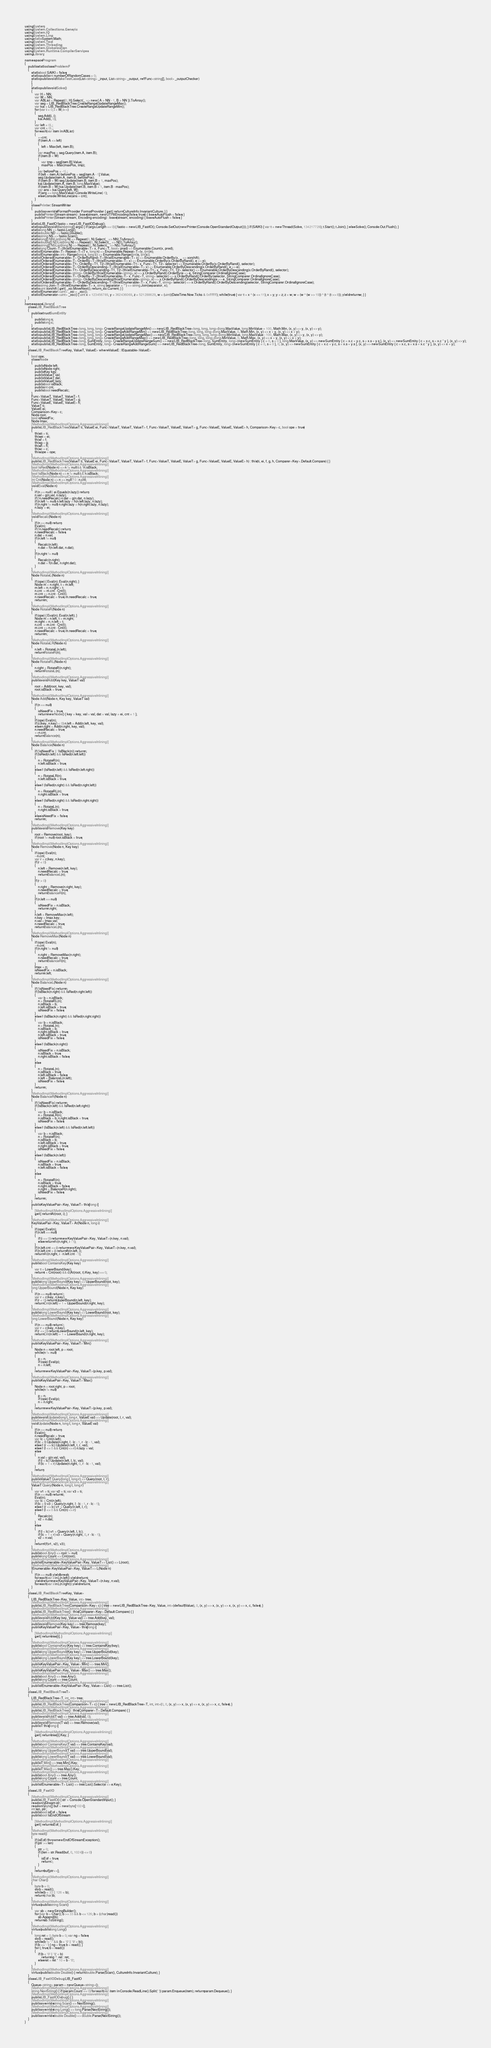Convert code to text. <code><loc_0><loc_0><loc_500><loc_500><_C#_>using System;
using System.Collections.Generic;
using System.IO;
using System.Linq;
using static System.Math;
using System.Text;
using System.Threading;
using System.Globalization;
using System.Runtime.CompilerServices;
using Library;

namespace Program
{
    public static class ProblemF
    {
        static bool SAIKI = false;
        static public int numberOfRandomCases = 0;
        static public void MakeTestCase(List<string> _input, List<string> _output, ref Func<string[], bool> _outputChecker)
        {
        }
        static public void Solve()
        {
            var H = NN;
            var W = NN;
            var ABList = Repeat(0, H).Select(_ => new { A = NN - 1, B = NN }).ToArray();
            var seg = LIB_RedBlackTree.CreateRangeUpdateRangeMax();
            var kai = LIB_RedBlackTree.CreateRangeUpdateRangeMin();
            for (var i = 0; i < W; i++)
            {
                seg.Add(i, i);
                kai.Add(i, 0);
            }
            var left = 0L;
            var cnt = 0L;
            foreach (var item in ABList)
            {
                ++cnt;
                if (item.A <= left)
                {
                    left = Max(left, item.B);
                }
                var maxPos = seg.Query(item.A, item.B);
                if (item.B < W)
                {
                    var tmp = seg[item.B].Value;
                    maxPos = Max(maxPos, tmp);
                }
                var beforePos = -1L;
                if (left < item.A) beforePos = seg[item.A - 1].Value;
                seg.Update(item.A, item.B, beforePos);
                if (item.B < W) seg.Update(item.B, item.B + 1, maxPos);
                kai.Update(item.A, item.B, long.MaxValue);
                if (item.B < W) kai.Update(item.B, item.B + 1, item.B - maxPos);
                var ans = kai.Query(left, W);
                if (ans == long.MaxValue) Console.WriteLine(-1);
                else Console.WriteLine(ans + cnt);
            }
        }
        class Printer : StreamWriter
        {
            public override IFormatProvider FormatProvider { get { return CultureInfo.InvariantCulture; } }
            public Printer(Stream stream) : base(stream, new UTF8Encoding(false, true)) { base.AutoFlush = false; }
            public Printer(Stream stream, Encoding encoding) : base(stream, encoding) { base.AutoFlush = false; }
        }
        static LIB_FastIO fastio = new LIB_FastIODebug();
        static public void Main(string[] args) { if (args.Length == 0) { fastio = new LIB_FastIO(); Console.SetOut(new Printer(Console.OpenStandardOutput())); } if (SAIKI) { var t = new Thread(Solve, 134217728); t.Start(); t.Join(); } else Solve(); Console.Out.Flush(); }
        static long NN => fastio.Long();
        static double ND => fastio.Double();
        static string NS => fastio.Scan();
        static long[] NNList(long N) => Repeat(0, N).Select(_ => NN).ToArray();
        static double[] NDList(long N) => Repeat(0, N).Select(_ => ND).ToArray();
        static string[] NSList(long N) => Repeat(0, N).Select(_ => NS).ToArray();
        static long Count<T>(this IEnumerable<T> x, Func<T, bool> pred) => Enumerable.Count(x, pred);
        static IEnumerable<T> Repeat<T>(T v, long n) => Enumerable.Repeat<T>(v, (int)n);
        static IEnumerable<int> Range(long s, long c) => Enumerable.Range((int)s, (int)c);
        static IOrderedEnumerable<T> OrderByRand<T>(this IEnumerable<T> x) => Enumerable.OrderBy(x, _ => xorshift);
        static IOrderedEnumerable<T> OrderBy<T>(this IEnumerable<T> x) => Enumerable.OrderBy(x.OrderByRand(), e => e);
        static IOrderedEnumerable<T1> OrderBy<T1, T2>(this IEnumerable<T1> x, Func<T1, T2> selector) => Enumerable.OrderBy(x.OrderByRand(), selector);
        static IOrderedEnumerable<T> OrderByDescending<T>(this IEnumerable<T> x) => Enumerable.OrderByDescending(x.OrderByRand(), e => e);
        static IOrderedEnumerable<T1> OrderByDescending<T1, T2>(this IEnumerable<T1> x, Func<T1, T2> selector) => Enumerable.OrderByDescending(x.OrderByRand(), selector);
        static IOrderedEnumerable<string> OrderBy(this IEnumerable<string> x) => x.OrderByRand().OrderBy(e => e, StringComparer.OrdinalIgnoreCase);
        static IOrderedEnumerable<T> OrderBy<T>(this IEnumerable<T> x, Func<T, string> selector) => x.OrderByRand().OrderBy(selector, StringComparer.OrdinalIgnoreCase);
        static IOrderedEnumerable<string> OrderByDescending(this IEnumerable<string> x) => x.OrderByRand().OrderByDescending(e => e, StringComparer.OrdinalIgnoreCase);
        static IOrderedEnumerable<T> OrderByDescending<T>(this IEnumerable<T> x, Func<T, string> selector) => x.OrderByRand().OrderByDescending(selector, StringComparer.OrdinalIgnoreCase);
        static string Join<T>(this IEnumerable<T> x, string separator = "") => string.Join(separator, x);
        static uint xorshift { get { _xsi.MoveNext(); return _xsi.Current; } }
        static IEnumerator<uint> _xsi = _xsc();
        static IEnumerator<uint> _xsc() { uint x = 123456789, y = 362436069, z = 521288629, w = (uint)(DateTime.Now.Ticks & 0xffffffff); while (true) { var t = x ^ (x << 11); x = y; y = z; z = w; w = (w ^ (w >> 19)) ^ (t ^ (t >> 8)); yield return w; } }
    }
}
namespace Library {
    class LIB_RedBlackTree
    {
        public struct SumEntity
        {
            public long s;
            public long c;
        }
        static public LIB_RedBlackTree<long, long, long> CreateRangeUpdateRangeMin() => new LIB_RedBlackTree<long, long, long>(long.MaxValue, long.MinValue + 100, Math.Min, (x, y) => y, (x, y) => y);
        static public LIB_RedBlackTree<long, long, long> CreateRangeAddRangeMin() => new LIB_RedBlackTree<long, long, long>(long.MaxValue, 0, Math.Min, (x, y) => x + y, (x, y) => x + y);
        static public LIB_RedBlackTree<long, long, long> CreateRangeUpdateRangeMax() => new LIB_RedBlackTree<long, long, long>(long.MinValue, long.MaxValue - 100, Math.Max, (x, y) => y, (x, y) => y);
        static public LIB_RedBlackTree<long, long, long> CreateRangeAddRangeMax() => new LIB_RedBlackTree<long, long, long>(long.MinValue, 0, Math.Max, (x, y) => x + y, (x, y) => x + y);
        static public LIB_RedBlackTree<long, SumEntity, long> CreateRangeUpdateRangeSum() => new LIB_RedBlackTree<long, SumEntity, long>(new SumEntity { c = 0, s = 0 }, long.MaxValue, (x, y) => new SumEntity { c = x.c + y.c, s = x.s + y.s }, (x, y) => new SumEntity { c = x.c, s = x.c * y }, (x, y) => y);
        static public LIB_RedBlackTree<long, SumEntity, long> CreateRangeAddRangeSum() => new LIB_RedBlackTree<long, SumEntity, long>(new SumEntity { c = 0, s = 0 }, 0, (x, y) => new SumEntity { c = x.c + y.c, s = x.s + y.s }, (x, y) => new SumEntity { c = x.c, s = x.s + x.c * y }, (x, y) => x + y);
    }
    class LIB_RedBlackTree<Key, ValueT, ValueE> where ValueE : IEquatable<ValueE>
    {
        bool ope;
        class Node
        {
            public Node left;
            public Node right;
            public Key key;
            public ValueT val;
            public ValueT dat;
            public ValueE lazy;
            public bool isBlack;
            public int cnt;
            public bool needRecalc;
        }
        Func<ValueT, ValueT, ValueT> f;
        Func<ValueT, ValueE, ValueT> g;
        Func<ValueE, ValueE, ValueE> h;
        ValueT ti;
        ValueE ei;
        Comparison<Key> c;
        Node root;
        bool isNeedFix;
        Node lmax;
        [MethodImpl(MethodImplOptions.AggressiveInlining)]
        public LIB_RedBlackTree(ValueT ti, ValueE ei, Func<ValueT, ValueT, ValueT> f, Func<ValueT, ValueE, ValueT> g, Func<ValueE, ValueE, ValueE> h, Comparison<Key> c, bool ope = true)
        {
            this.ti = ti;
            this.ei = ei;
            this.f = f;
            this.g = g;
            this.h = h;
            this.c = c;
            this.ope = ope;
        }
        [MethodImpl(MethodImplOptions.AggressiveInlining)]
        public LIB_RedBlackTree(ValueT ti, ValueE ei, Func<ValueT, ValueT, ValueT> f, Func<ValueT, ValueE, ValueT> g, Func<ValueE, ValueE, ValueE> h) : this(ti, ei, f, g, h, Comparer<Key>.Default.Compare) { }
        [MethodImpl(MethodImplOptions.AggressiveInlining)]
        bool IsRed(Node n) => n != null && !n.isBlack;
        [MethodImpl(MethodImplOptions.AggressiveInlining)]
        bool IsBlack(Node n) => n != null && n.isBlack;
        [MethodImpl(MethodImplOptions.AggressiveInlining)]
        int Cnt(Node n) => n == null ? 0 : n.cnt;
        [MethodImpl(MethodImplOptions.AggressiveInlining)]
        void Eval(Node n)
        {
            if (n == null || ei.Equals(n.lazy)) return;
            n.val = g(n.val, n.lazy);
            if (!n.needRecalc) n.dat = g(n.dat, n.lazy);
            if (n.left != null) n.left.lazy = h(n.left.lazy, n.lazy);
            if (n.right != null) n.right.lazy = h(n.right.lazy, n.lazy);
            n.lazy = ei;
        }
        [MethodImpl(MethodImplOptions.AggressiveInlining)]
        void Recalc(Node n)
        {
            if (n == null) return;
            Eval(n);
            if (!n.needRecalc) return;
            n.needRecalc = false;
            n.dat = n.val;
            if (n.left != null)
            {
                Recalc(n.left);
                n.dat = f(n.left.dat, n.dat);
            }
            if (n.right != null)
            {
                Recalc(n.right);
                n.dat = f(n.dat, n.right.dat);
            }
        }
        [MethodImpl(MethodImplOptions.AggressiveInlining)]
        Node RotateL(Node n)
        {
            if (ope) { Eval(n); Eval(n.right); }
            Node m = n.right, t = m.left;
            m.left = n; n.right = t;
            n.cnt -= m.cnt - Cnt(t);
            m.cnt += n.cnt - Cnt(t);
            n.needRecalc = true; m.needRecalc = true;
            return m;
        }
        [MethodImpl(MethodImplOptions.AggressiveInlining)]
        Node RotateR(Node n)
        {
            if (ope) { Eval(n); Eval(n.left); }
            Node m = n.left, t = m.right;
            m.right = n; n.left = t;
            n.cnt -= m.cnt - Cnt(t);
            m.cnt += n.cnt - Cnt(t);
            n.needRecalc = true; m.needRecalc = true;
            return m;
        }
        [MethodImpl(MethodImplOptions.AggressiveInlining)]
        Node RotateLR(Node n)
        {
            n.left = RotateL(n.left);
            return RotateR(n);
        }
        [MethodImpl(MethodImplOptions.AggressiveInlining)]
        Node RotateRL(Node n)
        {
            n.right = RotateR(n.right);
            return RotateL(n);
        }
        [MethodImpl(MethodImplOptions.AggressiveInlining)]
        public void Add(Key key, ValueT val)
        {
            root = Add(root, key, val);
            root.isBlack = true;
        }
        [MethodImpl(MethodImplOptions.AggressiveInlining)]
        Node Add(Node n, Key key, ValueT val)
        {
            if (n == null)
            {
                isNeedFix = true;
                return new Node() { key = key, val = val, dat = val, lazy = ei, cnt = 1 };
            }
            if (ope) Eval(n);
            if (c(key, n.key) < 0) n.left = Add(n.left, key, val);
            else n.right = Add(n.right, key, val);
            n.needRecalc = true;
            ++n.cnt;
            return Balance(n);
        }
        [MethodImpl(MethodImplOptions.AggressiveInlining)]
        Node Balance(Node n)
        {
            if (!isNeedFix || !IsBlack(n)) return n;
            if (IsRed(n.left) && IsRed(n.left.left))
            {
                n = RotateR(n);
                n.left.isBlack = true;
            }
            else if (IsRed(n.left) && IsRed(n.left.right))
            {
                n = RotateLR(n);
                n.left.isBlack = true;
            }
            else if (IsRed(n.right) && IsRed(n.right.left))
            {
                n = RotateRL(n);
                n.right.isBlack = true;
            }
            else if (IsRed(n.right) && IsRed(n.right.right))
            {
                n = RotateL(n);
                n.right.isBlack = true;
            }
            else isNeedFix = false;
            return n;
        }
        [MethodImpl(MethodImplOptions.AggressiveInlining)]
        public void Remove(Key key)
        {
            root = Remove(root, key);
            if (root != null) root.isBlack = true;
        }
        [MethodImpl(MethodImplOptions.AggressiveInlining)]
        Node Remove(Node n, Key key)
        {
            if (ope) Eval(n);
            --n.cnt;
            var r = c(key, n.key);
            if (r < 0)
            {
                n.left = Remove(n.left, key);
                n.needRecalc = true;
                return BalanceL(n);
            }
            if (r > 0)
            {
                n.right = Remove(n.right, key);
                n.needRecalc = true;
                return BalanceR(n);
            }
            if (n.left == null)
            {
                isNeedFix = n.isBlack;
                return n.right;
            }
            n.left = RemoveMax(n.left);
            n.key = lmax.key;
            n.val = lmax.val;
            n.needRecalc = true;
            return BalanceL(n);
        }
        [MethodImpl(MethodImplOptions.AggressiveInlining)]
        Node RemoveMax(Node n)
        {
            if (ope) Eval(n);
            --n.cnt;
            if (n.right != null)
            {
                n.right = RemoveMax(n.right);
                n.needRecalc = true;
                return BalanceR(n);
            }
            lmax = n;
            isNeedFix = n.isBlack;
            return n.left;
        }
        [MethodImpl(MethodImplOptions.AggressiveInlining)]
        Node BalanceL(Node n)
        {
            if (!isNeedFix) return n;
            if (IsBlack(n.right) && IsRed(n.right.left))
            {
                var b = n.isBlack;
                n = RotateRL(n);
                n.isBlack = b;
                n.left.isBlack = true;
                isNeedFix = false;
            }
            else if (IsBlack(n.right) && IsRed(n.right.right))
            {
                var b = n.isBlack;
                n = RotateL(n);
                n.isBlack = b;
                n.right.isBlack = true;
                n.left.isBlack = true;
                isNeedFix = false;
            }
            else if (IsBlack(n.right))
            {
                isNeedFix = n.isBlack;
                n.isBlack = true;
                n.right.isBlack = false;
            }
            else
            {
                n = RotateL(n);
                n.isBlack = true;
                n.left.isBlack = false;
                n.left = BalanceL(n.left);
                isNeedFix = false;
            }
            return n;
        }
        [MethodImpl(MethodImplOptions.AggressiveInlining)]
        Node BalanceR(Node n)
        {
            if (!isNeedFix) return n;
            if (IsBlack(n.left) && IsRed(n.left.right))
            {
                var b = n.isBlack;
                n = RotateLR(n);
                n.isBlack = b; n.right.isBlack = true;
                isNeedFix = false;
            }
            else if (IsBlack(n.left) && IsRed(n.left.left))
            {
                var b = n.isBlack;
                n = RotateR(n);
                n.isBlack = b;
                n.left.isBlack = true;
                n.right.isBlack = true;
                isNeedFix = false;
            }
            else if (IsBlack(n.left))
            {
                isNeedFix = n.isBlack;
                n.isBlack = true;
                n.left.isBlack = false;
            }
            else
            {
                n = RotateR(n);
                n.isBlack = true;
                n.right.isBlack = false;
                n.right = BalanceR(n.right);
                isNeedFix = false;
            }
            return n;
        }
        public KeyValuePair<Key, ValueT> this[long i]
        {
            [MethodImpl(MethodImplOptions.AggressiveInlining)]
            get { return At(root, i); }
        }
        [MethodImpl(MethodImplOptions.AggressiveInlining)]
        KeyValuePair<Key, ValueT> At(Node n, long i)
        {
            if (ope) Eval(n);
            if (n.left == null)
            {
                if (i == 0) return new KeyValuePair<Key, ValueT>(n.key, n.val);
                else return At(n.right, i - 1);
            }
            if (n.left.cnt == i) return new KeyValuePair<Key, ValueT>(n.key, n.val);
            if (n.left.cnt > i) return At(n.left, i);
            return At(n.right, i - n.left.cnt - 1);
        }
        [MethodImpl(MethodImplOptions.AggressiveInlining)]
        public bool ContainsKey(Key key)
        {
            var t = LowerBound(key);
            return t < Cnt(root) && c(At(root, t).Key, key) == 0;
        }
        [MethodImpl(MethodImplOptions.AggressiveInlining)]
        public long UpperBound(Key key) => UpperBound(root, key);
        [MethodImpl(MethodImplOptions.AggressiveInlining)]
        long UpperBound(Node n, Key key)
        {
            if (n == null) return 0;
            var r = c(key, n.key);
            if (r < 0) return UpperBound(n.left, key);
            return Cnt(n.left) + 1 + UpperBound(n.right, key);
        }
        [MethodImpl(MethodImplOptions.AggressiveInlining)]
        public long LowerBound(Key key) => LowerBound(root, key);
        [MethodImpl(MethodImplOptions.AggressiveInlining)]
        long LowerBound(Node n, Key key)
        {
            if (n == null) return 0;
            var r = c(key, n.key);
            if (r <= 0) return LowerBound(n.left, key);
            return Cnt(n.left) + 1 + LowerBound(n.right, key);
        }
        [MethodImpl(MethodImplOptions.AggressiveInlining)]
        public KeyValuePair<Key, ValueT> Min()
        {
            Node n = root.left, p = root;
            while (n != null)
            {
                p = n;
                if (ope) Eval(p);
                n = n.left;
            }
            return new KeyValuePair<Key, ValueT>(p.key, p.val);
        }
        [MethodImpl(MethodImplOptions.AggressiveInlining)]
        public KeyValuePair<Key, ValueT> Max()
        {
            Node n = root.right, p = root;
            while (n != null)
            {
                p = n;
                if (ope) Eval(p);
                n = n.right;
            }
            return new KeyValuePair<Key, ValueT>(p.key, p.val);
        }
        [MethodImpl(MethodImplOptions.AggressiveInlining)]
        public void Update(long l, long r, ValueE val) => Update(root, l, r, val);
        [MethodImpl(MethodImplOptions.AggressiveInlining)]
        void Update(Node n, long l, long r, ValueE val)
        {
            if (n == null) return;
            Eval(n);
            n.needRecalc = true;
            var lc = Cnt(n.left);
            if (lc < l) Update(n.right, l - lc - 1, r - lc - 1, val);
            else if (r <= lc) Update(n.left, l, r, val);
            else if (l <= 0 && Cnt(n) <= r) n.lazy = val;
            else
            {
                n.val = g(n.val, val);
                if (l < lc) Update(n.left, l, lc, val);
                if (lc + 1 < r) Update(n.right, 0, r - lc - 1, val);
            }
            return;
        }
        [MethodImpl(MethodImplOptions.AggressiveInlining)]
        public ValueT Query(long l, long r) => Query(root, l, r);
        [MethodImpl(MethodImplOptions.AggressiveInlining)]
        ValueT Query(Node n, long l, long r)
        {
            var v1 = ti; var v2 = ti; var v3 = ti;
            if (n == null) return ti;
            Eval(n);
            var lc = Cnt(n.left);
            if (lc < l) v3 = Query(n.right, l - lc - 1, r - lc - 1);
            else if (r <= lc) v1 = Query(n.left, l, r);
            else if (l <= 0 && Cnt(n) <= r)
            {
                Recalc(n);
                v2 = n.dat;
            }
            else
            {
                if (l < lc) v1 = Query(n.left, l, lc);
                if (lc + 1 < r) v3 = Query(n.right, 0, r - lc - 1);
                v2 = n.val;
            }
            return f(f(v1, v2), v3);
        }
        [MethodImpl(MethodImplOptions.AggressiveInlining)]
        public bool Any() => root != null;
        public long Count => Cnt(root);
        [MethodImpl(MethodImplOptions.AggressiveInlining)]
        public IEnumerable<KeyValuePair<Key, ValueT>> List() => L(root);
        [MethodImpl(MethodImplOptions.AggressiveInlining)]
        IEnumerable<KeyValuePair<Key, ValueT>> L(Node n)
        {
            if (n == null) yield break;
            foreach (var i in L(n.left)) yield return i;
            yield return new KeyValuePair<Key, ValueT>(n.key, n.val);
            foreach (var i in L(n.right)) yield return i;
        }
    }
    class LIB_RedBlackTree<Key, Value>
    {
        LIB_RedBlackTree<Key, Value, int> tree;
        [MethodImpl(MethodImplOptions.AggressiveInlining)]
        public LIB_RedBlackTree(Comparison<Key> c) { tree = new LIB_RedBlackTree<Key, Value, int>(default(Value), 0, (x, y) => x, (x, y) => x, (x, y) => x, c, false); }
        [MethodImpl(MethodImplOptions.AggressiveInlining)]
        public LIB_RedBlackTree() : this(Comparer<Key>.Default.Compare) { }
        [MethodImpl(MethodImplOptions.AggressiveInlining)]
        public void Add(Key key, Value val) => tree.Add(key, val);
        [MethodImpl(MethodImplOptions.AggressiveInlining)]
        public void Remove(Key key) => tree.Remove(key);
        public KeyValuePair<Key, Value> this[long i]
        {
            [MethodImpl(MethodImplOptions.AggressiveInlining)]
            get { return tree[i]; }
        }
        [MethodImpl(MethodImplOptions.AggressiveInlining)]
        public bool ContainsKey(Key key) => tree.ContainsKey(key);
        [MethodImpl(MethodImplOptions.AggressiveInlining)]
        public long UpperBound(Key key) => tree.UpperBound(key);
        [MethodImpl(MethodImplOptions.AggressiveInlining)]
        public long LowerBound(Key key) => tree.LowerBound(key);
        [MethodImpl(MethodImplOptions.AggressiveInlining)]
        public KeyValuePair<Key, Value> Min() => tree.Min();
        [MethodImpl(MethodImplOptions.AggressiveInlining)]
        public KeyValuePair<Key, Value> Max() => tree.Max();
        [MethodImpl(MethodImplOptions.AggressiveInlining)]
        public bool Any() => tree.Any();
        public long Count => tree.Count;
        [MethodImpl(MethodImplOptions.AggressiveInlining)]
        public IEnumerable<KeyValuePair<Key, Value>> List() => tree.List();
    }
    class LIB_RedBlackTree<T>
    {
        LIB_RedBlackTree<T, int, int> tree;
        [MethodImpl(MethodImplOptions.AggressiveInlining)]
        public LIB_RedBlackTree(Comparison<T> c) { tree = new LIB_RedBlackTree<T, int, int>(0, 0, (x, y) => x, (x, y) => x, (x, y) => x, c, false); }
        [MethodImpl(MethodImplOptions.AggressiveInlining)]
        public LIB_RedBlackTree() : this(Comparer<T>.Default.Compare) { }
        [MethodImpl(MethodImplOptions.AggressiveInlining)]
        public void Add(T val) => tree.Add(val, 0);
        [MethodImpl(MethodImplOptions.AggressiveInlining)]
        public void Remove(T val) => tree.Remove(val);
        public T this[long i]
        {
            [MethodImpl(MethodImplOptions.AggressiveInlining)]
            get { return tree[i].Key; }
        }
        [MethodImpl(MethodImplOptions.AggressiveInlining)]
        public bool ContainsKey(T val) => tree.ContainsKey(val);
        [MethodImpl(MethodImplOptions.AggressiveInlining)]
        public long UpperBound(T val) => tree.UpperBound(val);
        [MethodImpl(MethodImplOptions.AggressiveInlining)]
        public long LowerBound(T val) => tree.LowerBound(val);
        [MethodImpl(MethodImplOptions.AggressiveInlining)]
        public T Min() => tree.Min().Key;
        [MethodImpl(MethodImplOptions.AggressiveInlining)]
        public T Max() => tree.Max().Key;
        [MethodImpl(MethodImplOptions.AggressiveInlining)]
        public bool Any() => tree.Any();
        public long Count => tree.Count;
        [MethodImpl(MethodImplOptions.AggressiveInlining)]
        public IEnumerable<T> List() => tree.List().Select(e => e.Key);
    }
    class LIB_FastIO
    {
        [MethodImpl(MethodImplOptions.AggressiveInlining)]
        public LIB_FastIO() { str = Console.OpenStandardInput(); }
        readonly Stream str;
        readonly byte[] buf = new byte[1024];
        int len, ptr;
        public bool isEof = false;
        public bool IsEndOfStream
        {
            [MethodImpl(MethodImplOptions.AggressiveInlining)]
            get { return isEof; }
        }
        [MethodImpl(MethodImplOptions.AggressiveInlining)]
        byte read()
        {
            if (isEof) throw new EndOfStreamException();
            if (ptr >= len)
            {
                ptr = 0;
                if ((len = str.Read(buf, 0, 1024)) <= 0)
                {
                    isEof = true;
                    return 0;
                }
            }
            return buf[ptr++];
        }
        [MethodImpl(MethodImplOptions.AggressiveInlining)]
        char Char()
        {
            byte b = 0;
            do b = read();
            while (b < 33 || 126 < b);
            return (char)b;
        }
        [MethodImpl(MethodImplOptions.AggressiveInlining)]
        virtual public string Scan()
        {
            var sb = new StringBuilder();
            for (var b = Char(); b >= 33 && b <= 126; b = (char)read())
                sb.Append(b);
            return sb.ToString();
        }
        [MethodImpl(MethodImplOptions.AggressiveInlining)]
        virtual public long Long()
        {
            long ret = 0; byte b = 0; var ng = false;
            do b = read();
            while (b != '-' && (b < '0' || '9' < b));
            if (b == '-') { ng = true; b = read(); }
            for (; true; b = read())
            {
                if (b < '0' || '9' < b)
                    return ng ? -ret : ret;
                else ret = ret * 10 + b - '0';
            }
        }
        [MethodImpl(MethodImplOptions.AggressiveInlining)]
        virtual public double Double() { return double.Parse(Scan(), CultureInfo.InvariantCulture); }
    }
    class LIB_FastIODebug : LIB_FastIO
    {
        Queue<string> param = new Queue<string>();
        [MethodImpl(MethodImplOptions.AggressiveInlining)]
        string NextString() { if (param.Count == 0) foreach (var item in Console.ReadLine().Split(' ')) param.Enqueue(item); return param.Dequeue(); }
        [MethodImpl(MethodImplOptions.AggressiveInlining)]
        public LIB_FastIODebug() { }
        [MethodImpl(MethodImplOptions.AggressiveInlining)]
        public override string Scan() => NextString();
        [MethodImpl(MethodImplOptions.AggressiveInlining)]
        public override long Long() => long.Parse(NextString());
        [MethodImpl(MethodImplOptions.AggressiveInlining)]
        public override double Double() => double.Parse(NextString());
    }
}
</code> 